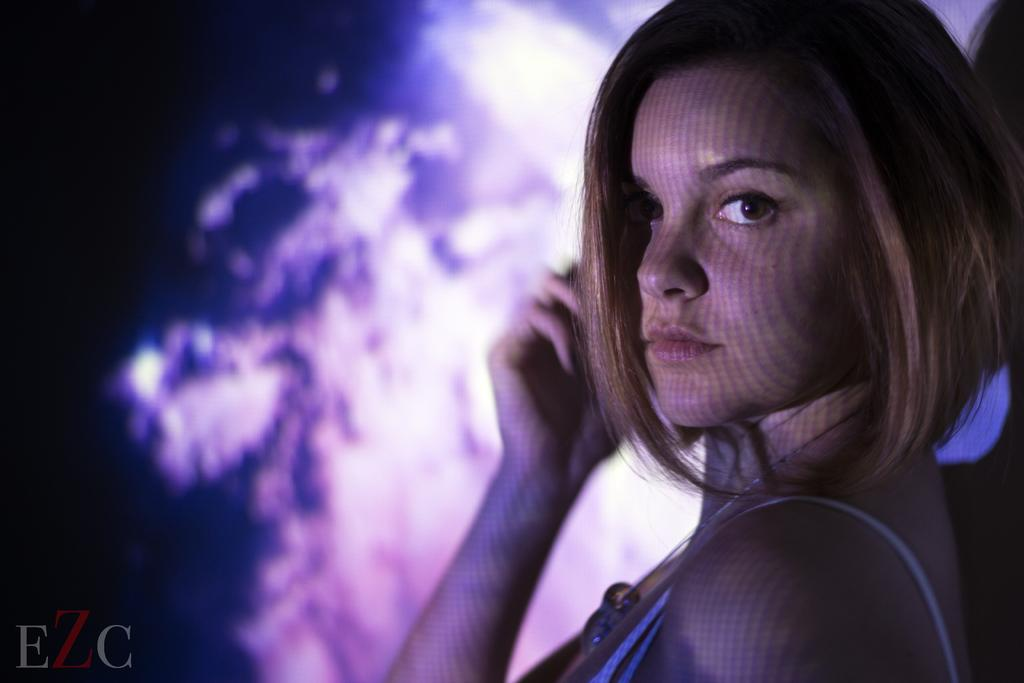Who is present in the image? There is a woman in the image. What can be found at the left bottom of the image? There is text at the left bottom of the image. Can you describe the background of the image? The background of the image is blurry. What type of brake is visible in the image? There is no brake present in the image. What kind of wrist support can be seen in the image? There is no wrist support visible in the image. 